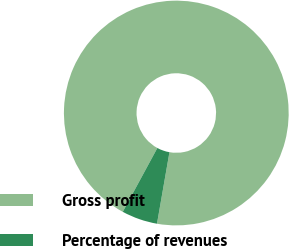Convert chart to OTSL. <chart><loc_0><loc_0><loc_500><loc_500><pie_chart><fcel>Gross profit<fcel>Percentage of revenues<nl><fcel>94.85%<fcel>5.15%<nl></chart> 